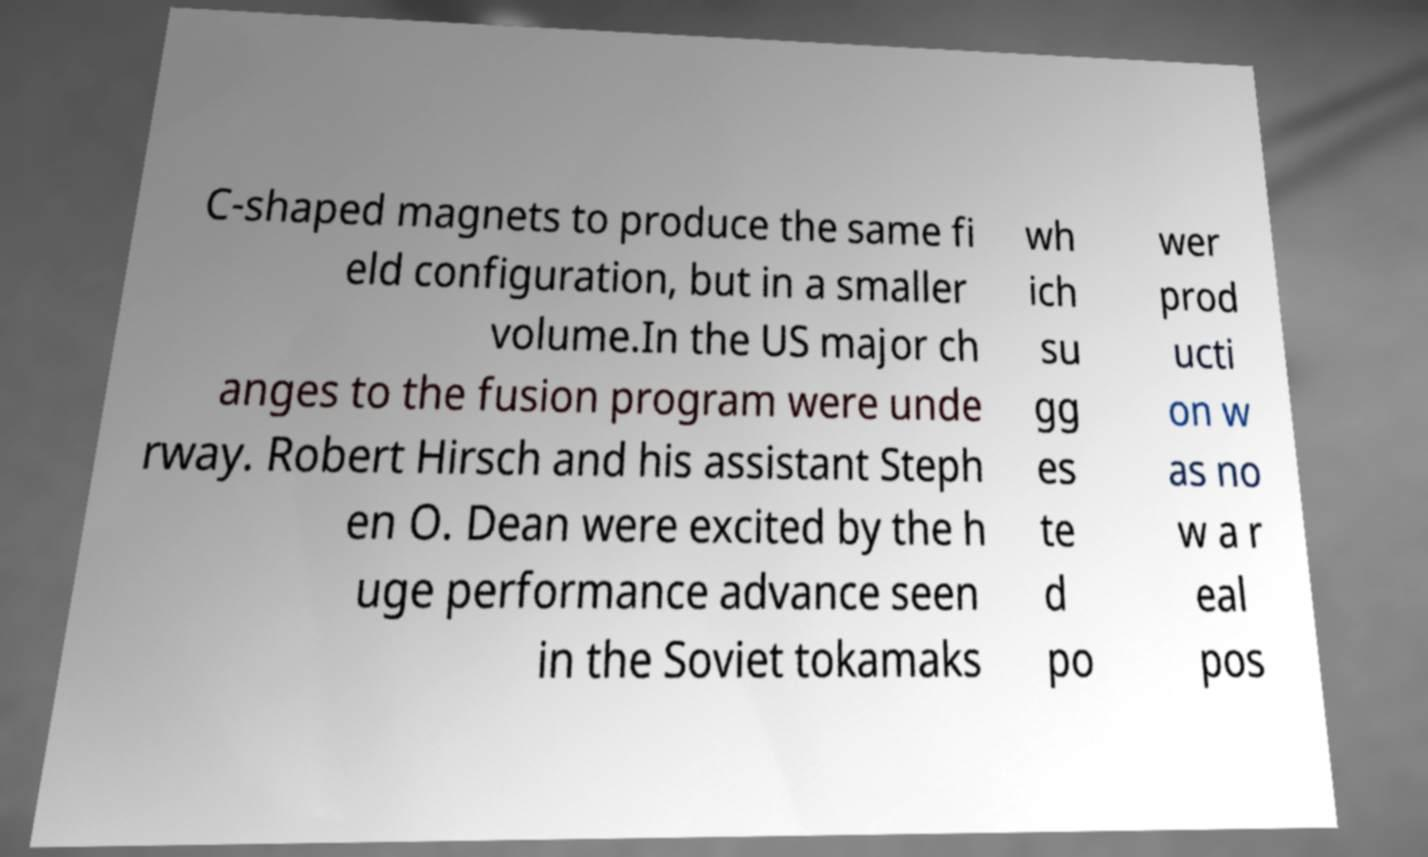Can you accurately transcribe the text from the provided image for me? C-shaped magnets to produce the same fi eld configuration, but in a smaller volume.In the US major ch anges to the fusion program were unde rway. Robert Hirsch and his assistant Steph en O. Dean were excited by the h uge performance advance seen in the Soviet tokamaks wh ich su gg es te d po wer prod ucti on w as no w a r eal pos 